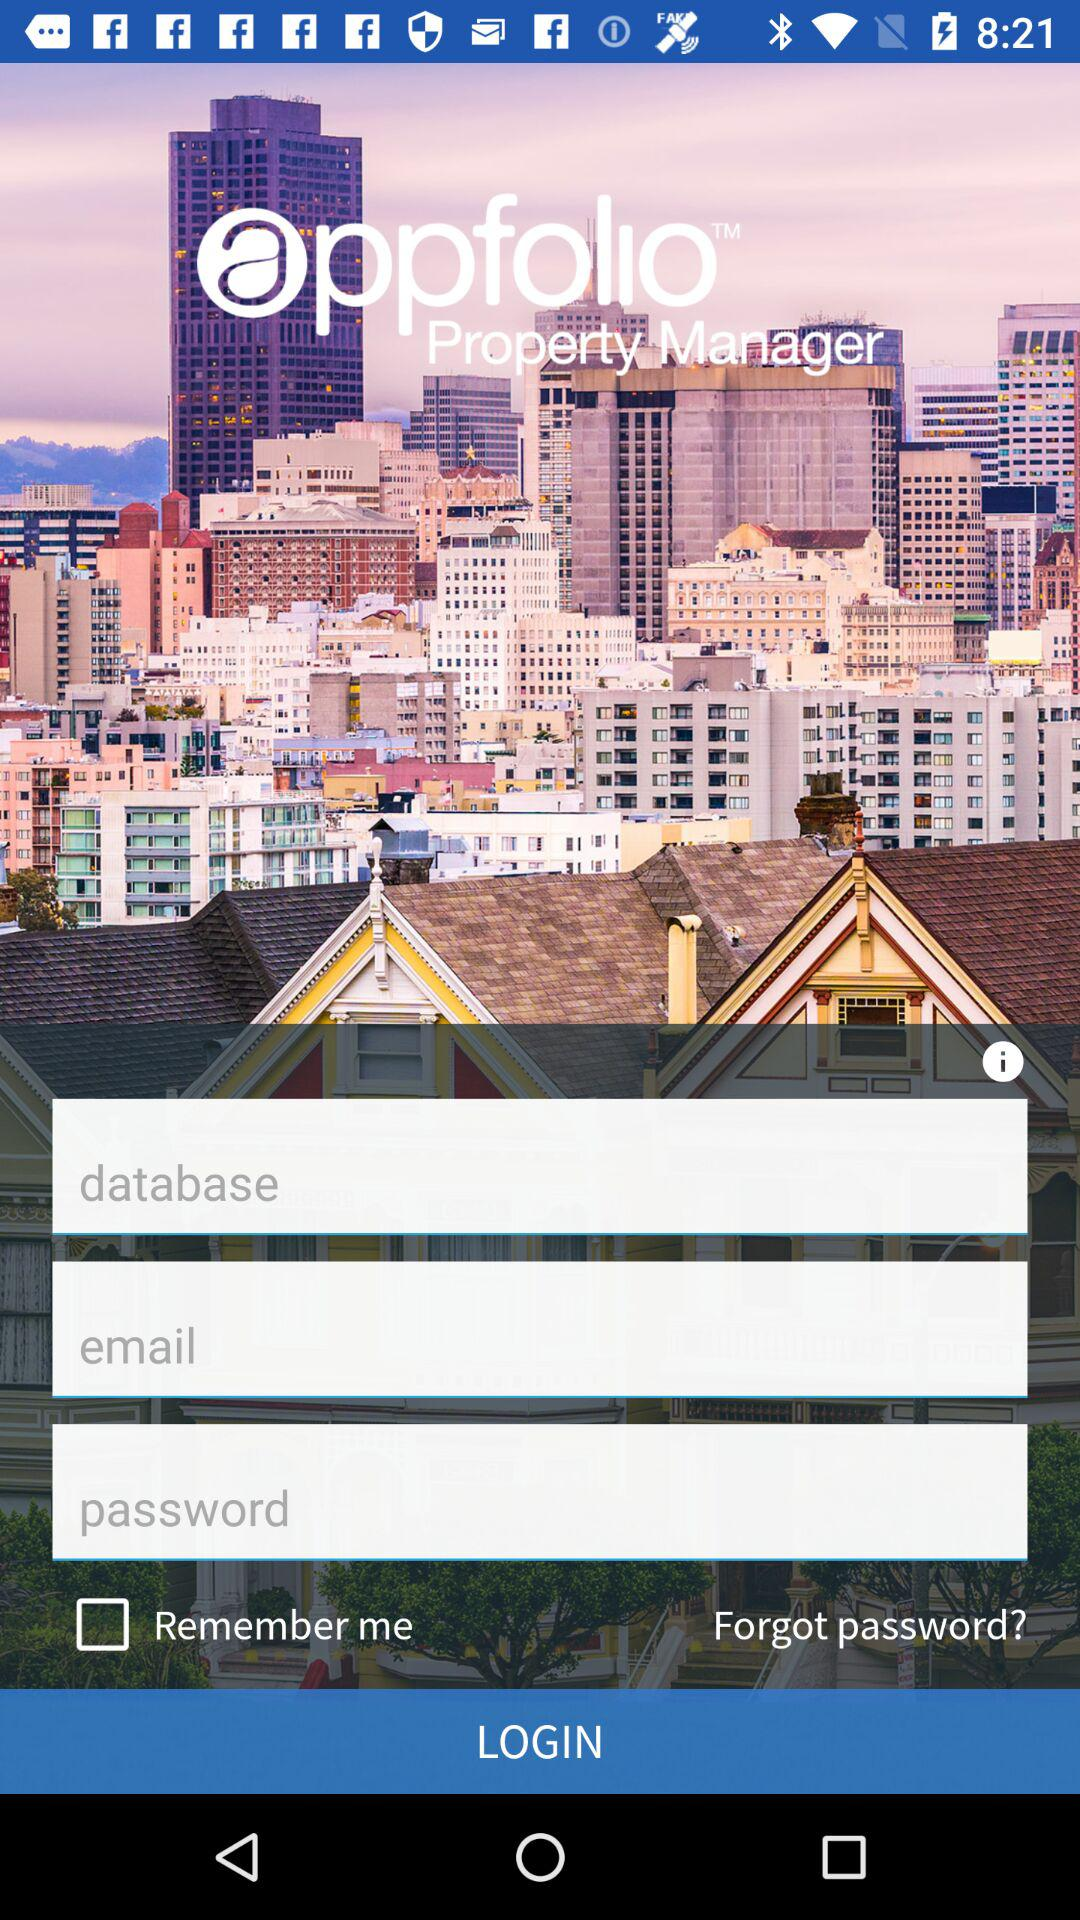Can we reset password?
When the provided information is insufficient, respond with <no answer>. <no answer> 